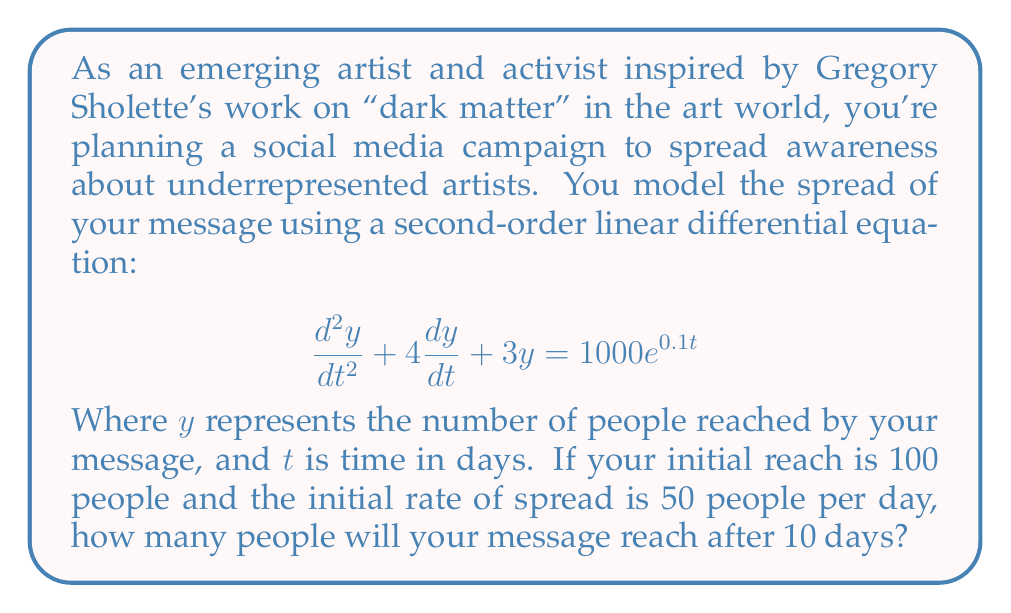Give your solution to this math problem. To solve this problem, we need to follow these steps:

1) The general solution to this second-order linear differential equation is:
   $$y = y_h + y_p$$
   where $y_h$ is the homogeneous solution and $y_p$ is the particular solution.

2) The homogeneous solution has the form:
   $$y_h = c_1e^{r_1t} + c_2e^{r_2t}$$
   where $r_1$ and $r_2$ are roots of the characteristic equation:
   $$r^2 + 4r + 3 = 0$$
   Solving this, we get $r_1 = -1$ and $r_2 = -3$

3) The particular solution has the form:
   $$y_p = Ae^{0.1t}$$
   Substituting this into the original equation:
   $$A(0.1^2 + 4(0.1) + 3)e^{0.1t} = 1000e^{0.1t}$$
   $$3.41A = 1000$$
   $$A \approx 293.26$$

4) So, the general solution is:
   $$y = c_1e^{-t} + c_2e^{-3t} + 293.26e^{0.1t}$$

5) Using the initial conditions:
   At $t=0$, $y(0) = 100$ and $y'(0) = 50$
   
   $$100 = c_1 + c_2 + 293.26$$
   $$50 = -c_1 - 3c_2 + 29.326$$

6) Solving these equations:
   $$c_1 \approx -131.63$$
   $$c_2 \approx -61.63$$

7) The final solution is:
   $$y = -131.63e^{-t} - 61.63e^{-3t} + 293.26e^{0.1t}$$

8) Evaluating at $t=10$:
   $$y(10) = -131.63e^{-10} - 61.63e^{-30} + 293.26e^{1}$$
   $$y(10) \approx 796.57$$

Therefore, after 10 days, your message will reach approximately 797 people.
Answer: 797 people 